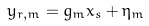Convert formula to latex. <formula><loc_0><loc_0><loc_500><loc_500>y _ { r , m } = g _ { m } x _ { s } + \eta _ { m }</formula> 